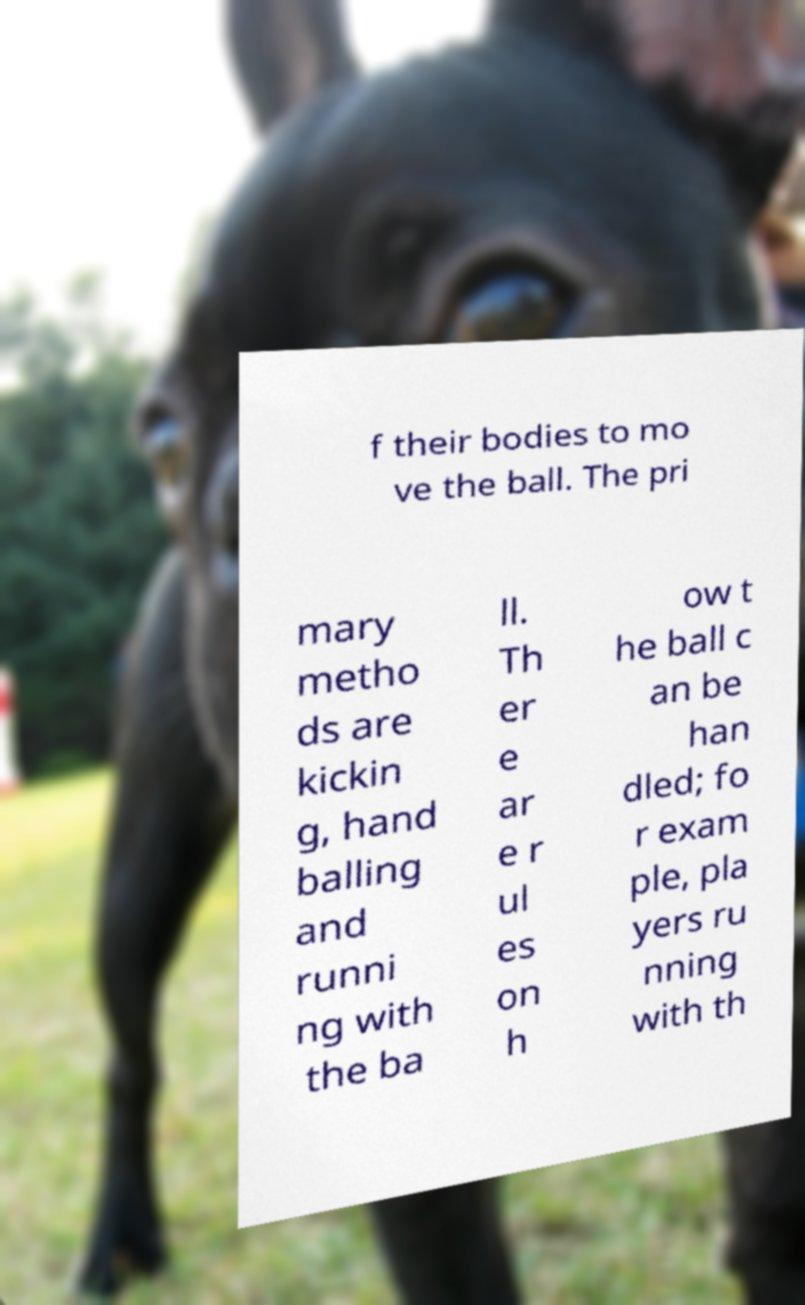For documentation purposes, I need the text within this image transcribed. Could you provide that? f their bodies to mo ve the ball. The pri mary metho ds are kickin g, hand balling and runni ng with the ba ll. Th er e ar e r ul es on h ow t he ball c an be han dled; fo r exam ple, pla yers ru nning with th 